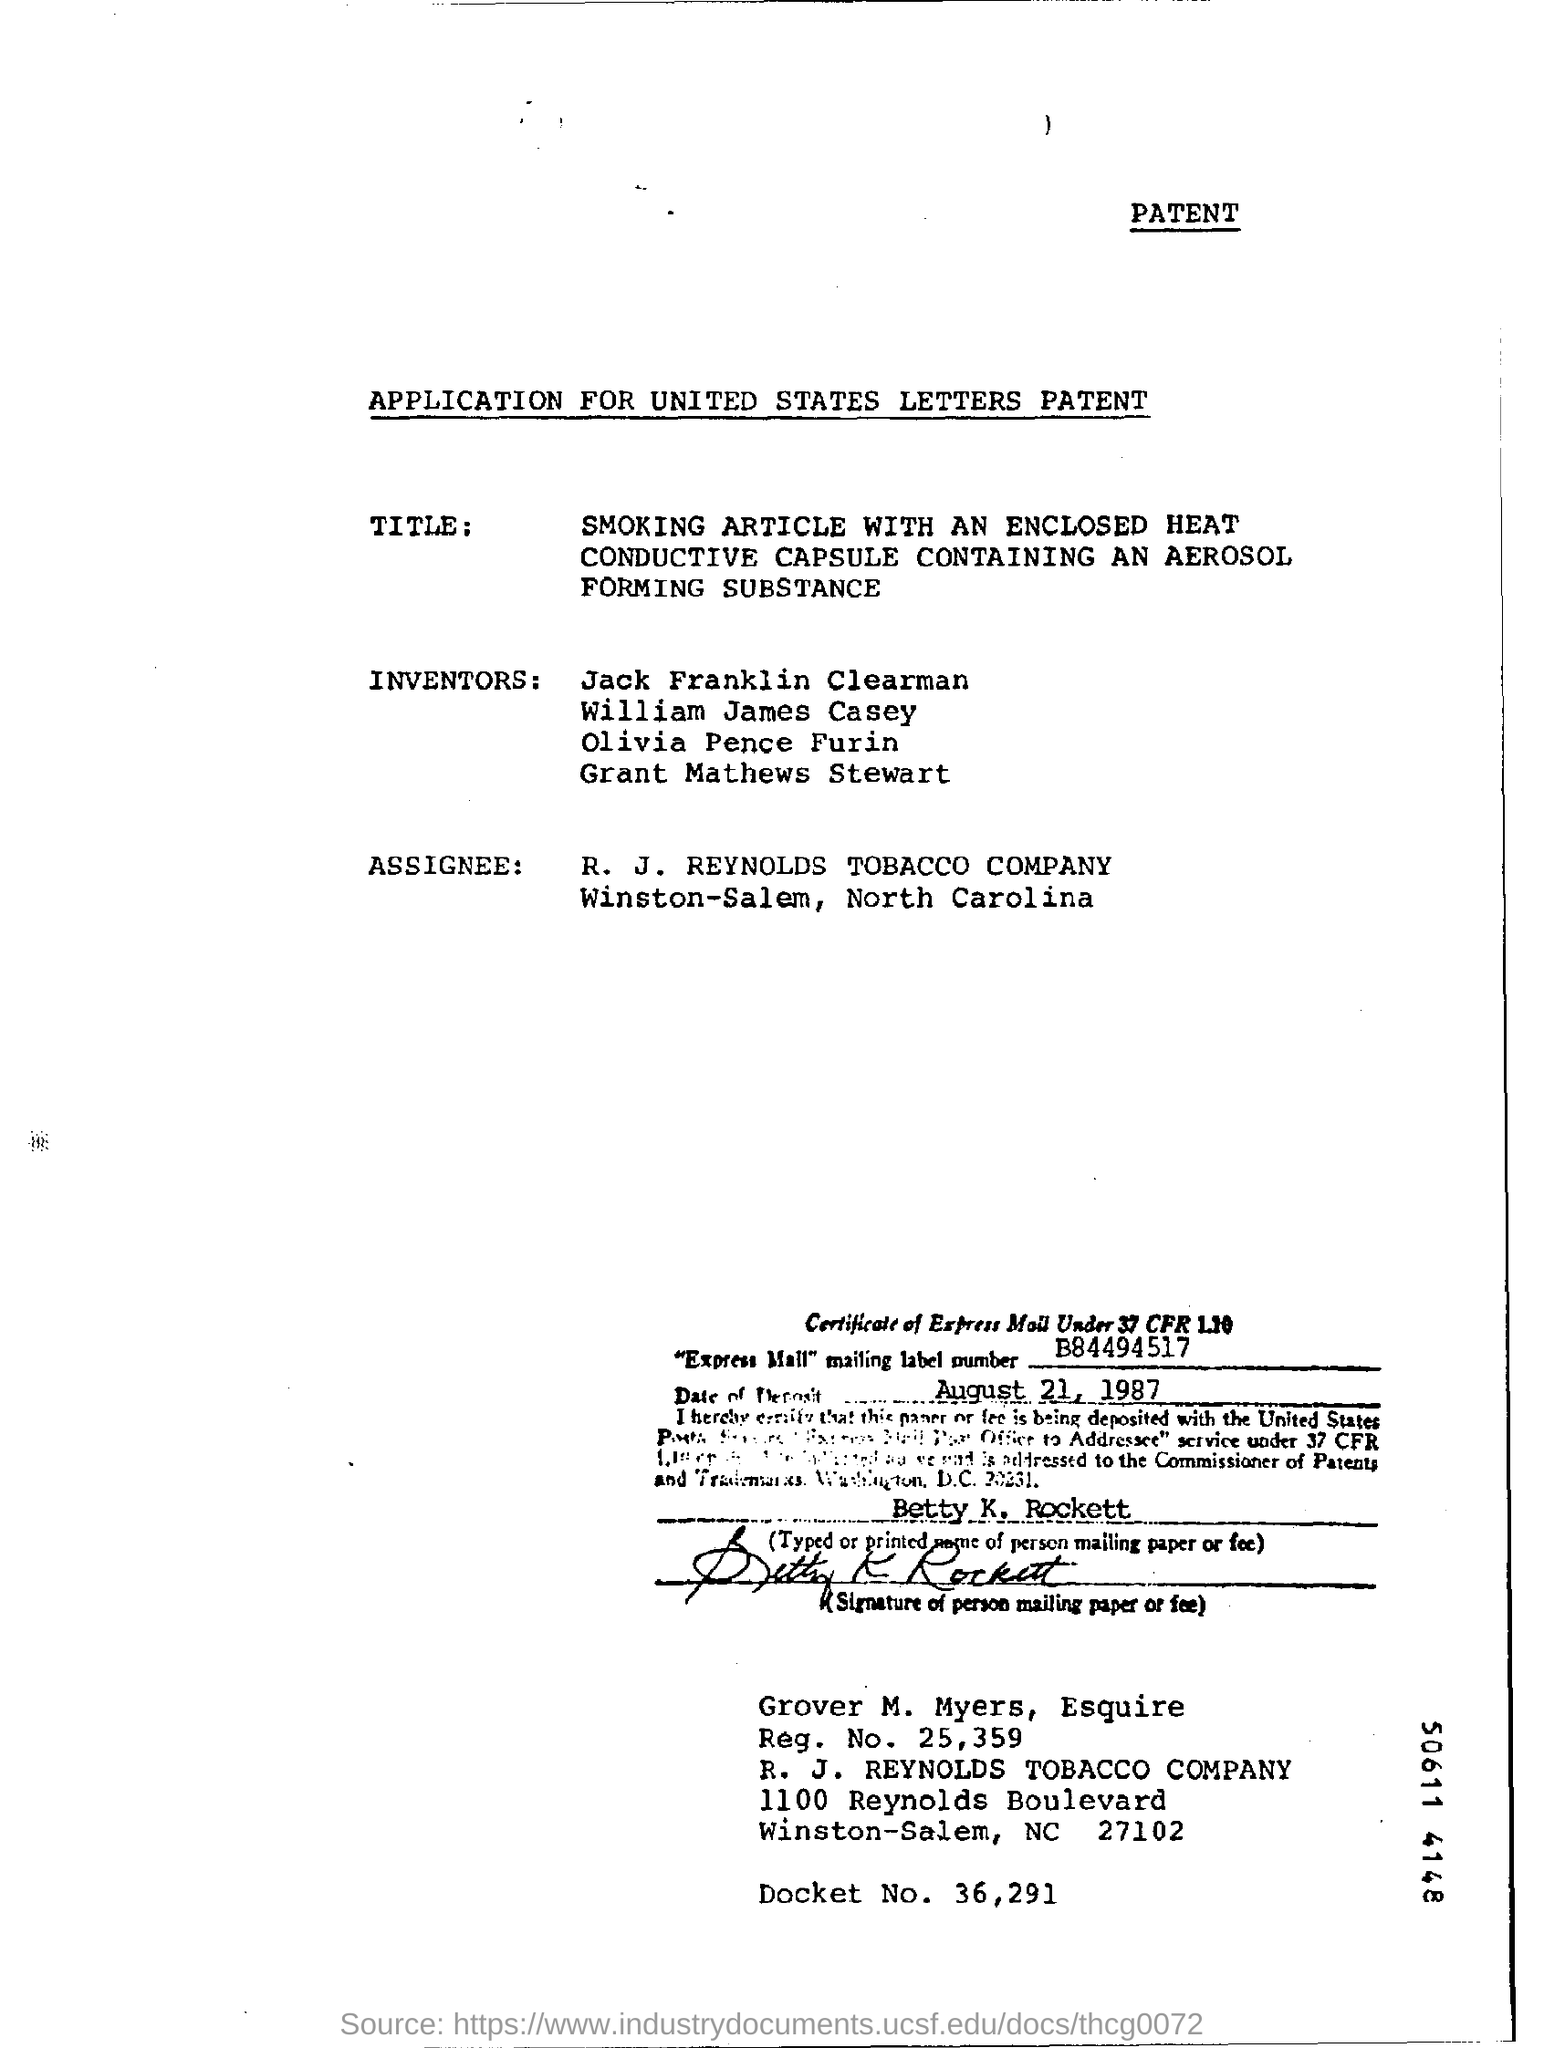What is the Company Name ?
Offer a terse response. R. J. REYNOLDS TOBACCO COMPANY. What is the Reg. No ?
Your response must be concise. 25,359. What is the Docket Number?
Your answer should be compact. 36,291. What is the date mentioned in the  document ?
Your answer should be very brief. August 21, 1987. What is the Mailing Label Number ?
Your response must be concise. B84494517. 